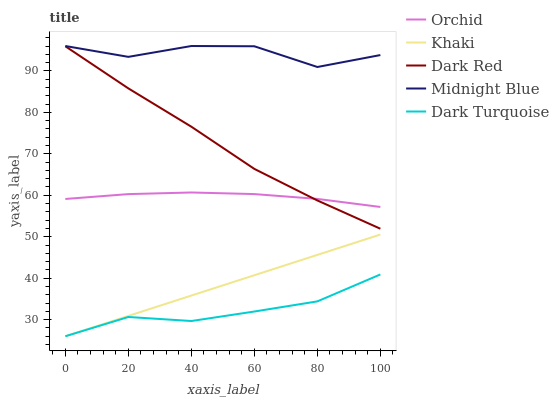Does Khaki have the minimum area under the curve?
Answer yes or no. No. Does Khaki have the maximum area under the curve?
Answer yes or no. No. Is Midnight Blue the smoothest?
Answer yes or no. No. Is Khaki the roughest?
Answer yes or no. No. Does Midnight Blue have the lowest value?
Answer yes or no. No. Does Khaki have the highest value?
Answer yes or no. No. Is Dark Turquoise less than Orchid?
Answer yes or no. Yes. Is Midnight Blue greater than Orchid?
Answer yes or no. Yes. Does Dark Turquoise intersect Orchid?
Answer yes or no. No. 